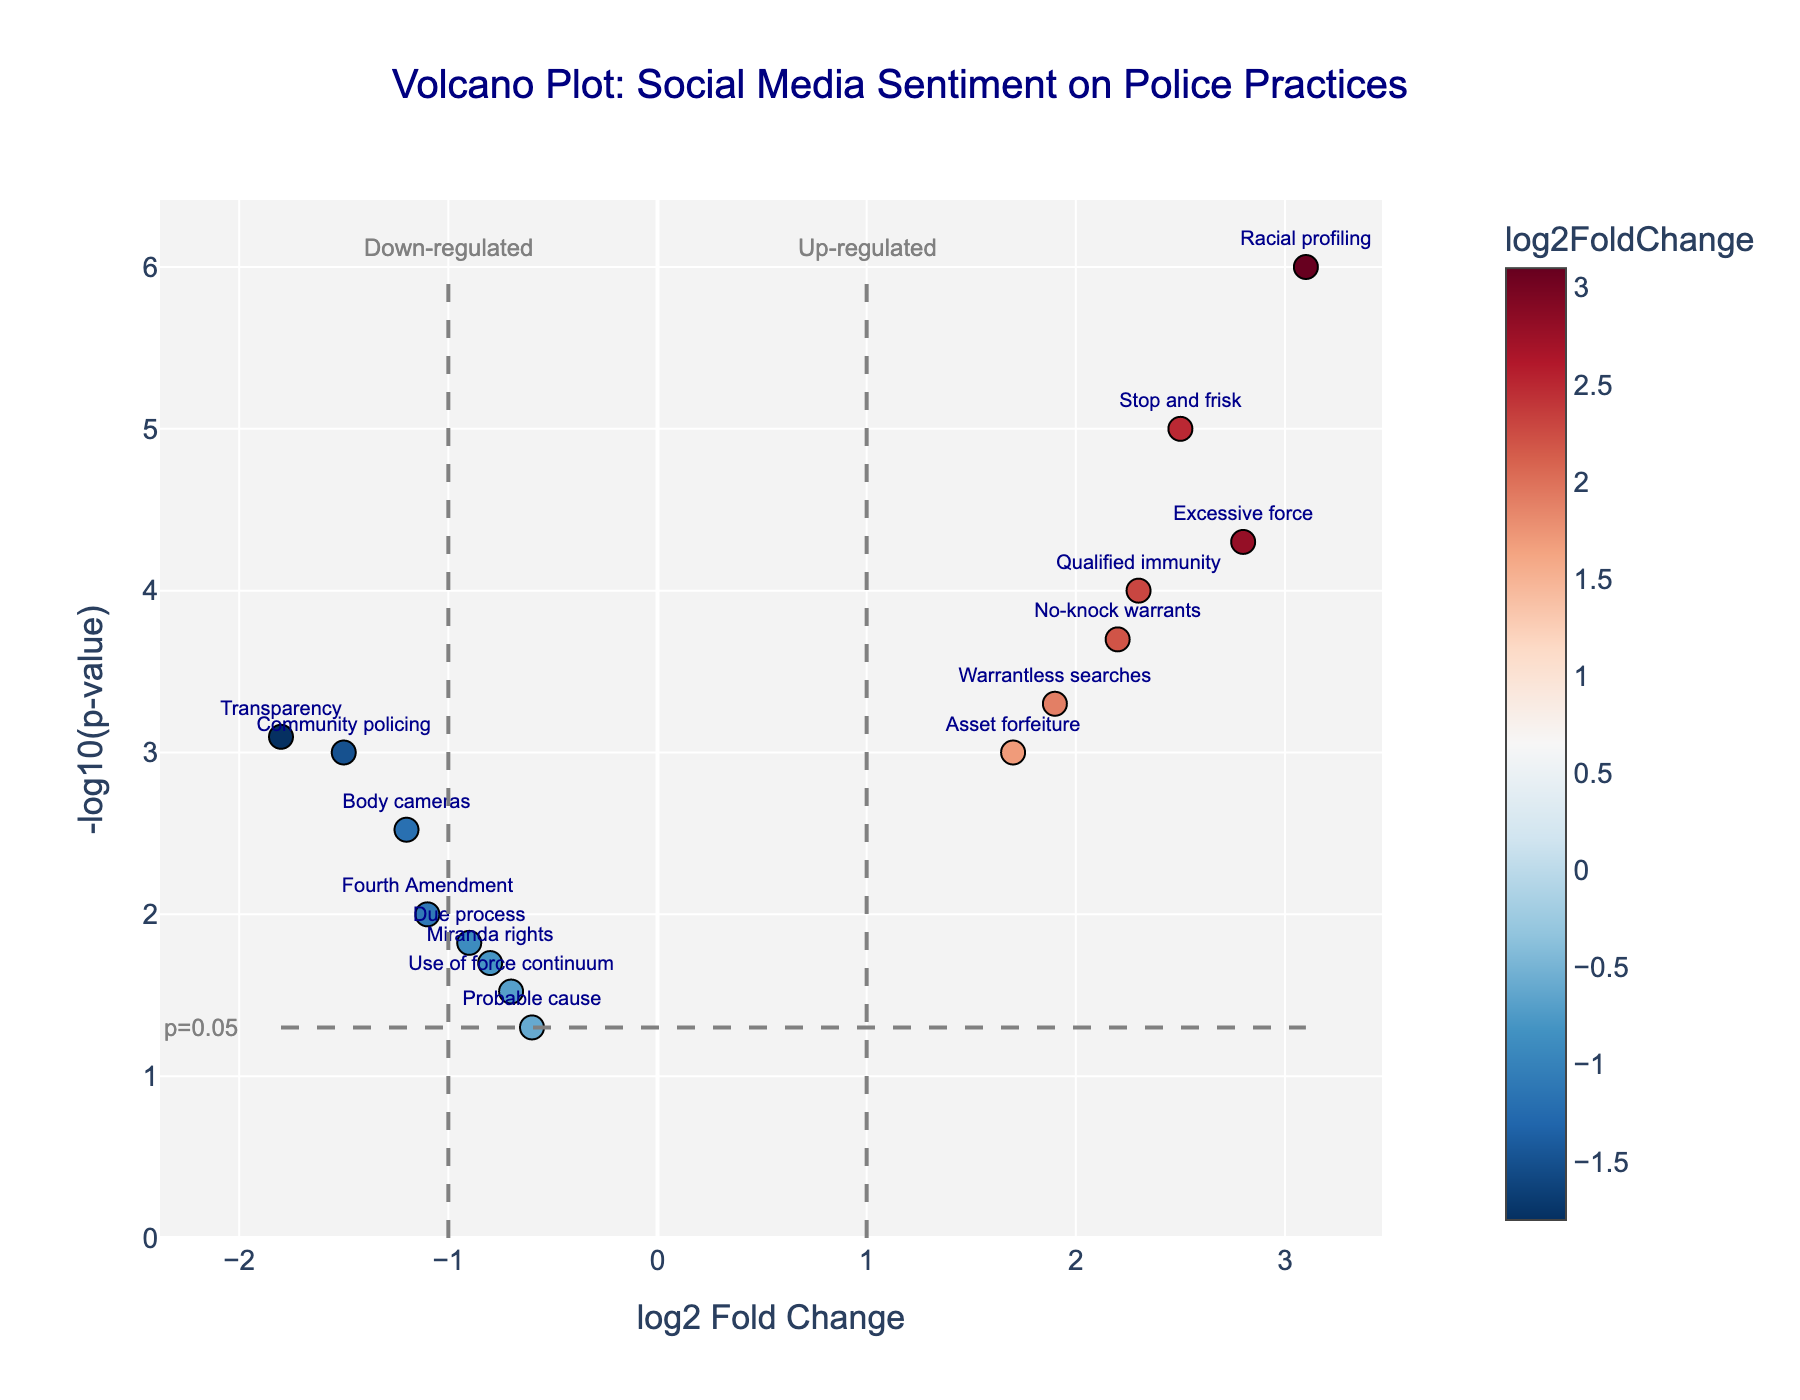Which term has the highest log2FoldChange? Identify the point with the highest x-axis (log2FoldChange) value on the plot. The term "Racial profiling" is positioned furthest to the right.
Answer: Racial profiling Which term has the lowest p-value? The lowest p-value corresponds to the highest y-axis (-log10(pvalue)) value on the plot. The term "Racial profiling" is positioned highest.
Answer: Racial profiling How many terms have a p-value less than 0.05? Identify points above the horizontal threshold line, which represents p=0.05. There are 12 points above this line.
Answer: 12 Which term is marked as the most down-regulated? Locate the point furthest to the left (-log2FoldChange) for down-regulation. The term "Transparency" is positioned furthest to the left.
Answer: Transparency Which terms fall into the up-regulated region (log2FoldChange > 1)? Identify points to the right of the vertical threshold at x=1. Terms include "Stop and frisk," "Warrantless searches," "Racial profiling," "No-knock warrants," "Asset forfeiture," "Excessive force," and "Qualified immunity."
Answer: Stop and frisk, Warrantless searches, Racial profiling, No-knock warrants, Asset forfeiture, Excessive force, Qualified immunity Which terms have both significant p-values (p < 0.05) and are down-regulated (log2FoldChange < -1)? Points need to be identified that are above the horizontal line and left of the vertical line at x=-1. Terms include "Body cameras," "Community policing," and "Transparency."
Answer: Body cameras, Community policing, Transparency What is the log2FoldChange value of "Qualified immunity"? Find the "Qualified immunity" label and check the x-axis value (log2FoldChange) for this term. It is approximately 2.3.
Answer: 2.3 What is the overall trend for "Miranda rights" based on the plot? Locate “Miranda rights” and determine its position relative to the vertical and horizontal thresholds. It is found in the down-regulated region (log2FoldChange < 0) with a log2FoldChange of -0.8 and above the horizontal threshold (significant p-value < 0.05).
Answer: Down-regulated and significant How does the public sentiment on "Use of force continuum" compare to "Excessive force"? Compare their positions on the plot. "Use of force continuum" is down-regulated (log2FoldChange < 0), while "Excessive force" is up-regulated (log2FoldChange > 1).
Answer: "Use of force continuum" is down-regulated, "Excessive force" is up-regulated 